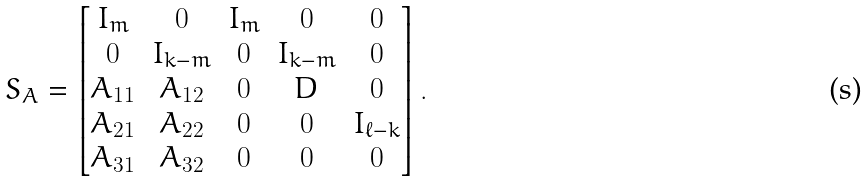<formula> <loc_0><loc_0><loc_500><loc_500>S _ { A } = \begin{bmatrix} I _ { m } & 0 & I _ { m } & 0 & 0 \\ 0 & I _ { k - m } & 0 & I _ { k - m } & 0 \\ A _ { 1 1 } & A _ { 1 2 } & 0 & D & 0 \\ A _ { 2 1 } & A _ { 2 2 } & 0 & 0 & I _ { \ell - k } \\ A _ { 3 1 } & A _ { 3 2 } & 0 & 0 & 0 \end{bmatrix} .</formula> 